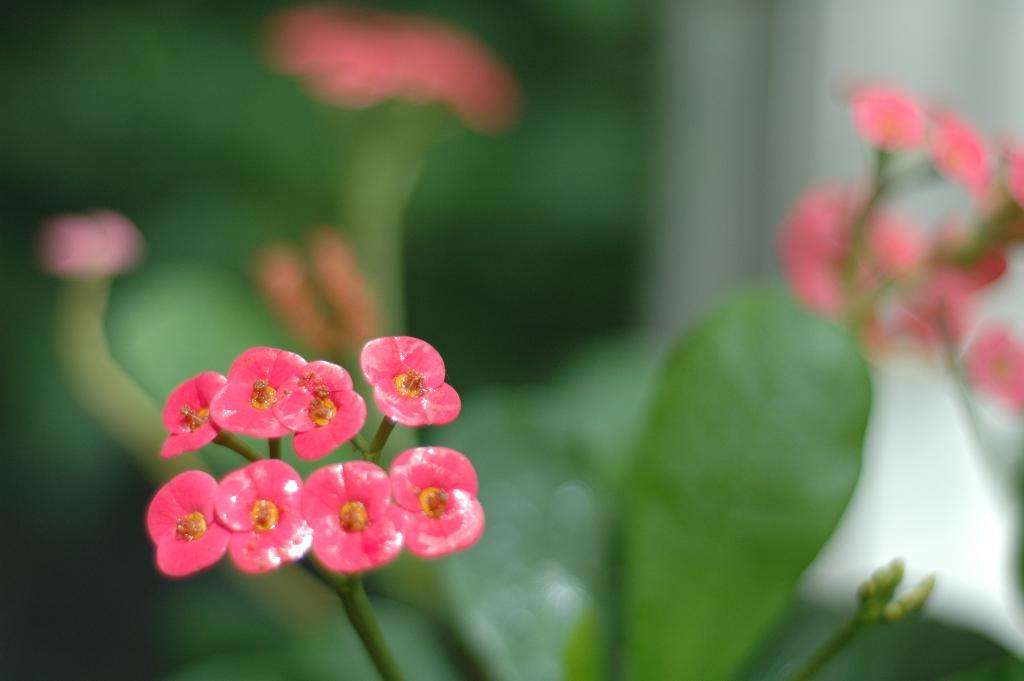What is the focus of the image? The image is zoomed in, so the focus is on a specific area or subject. What can be seen on the left side of the image? There are flowers on the left side of the image. What is present in the background of the image? There is a plant and other objects visible in the background of the image. What type of government is depicted in the image? There is no government depicted in the image; it features flowers, a plant, and other objects. What role does the father play in the image? There is no father present in the image; it focuses on flowers, a plant, and other objects. 